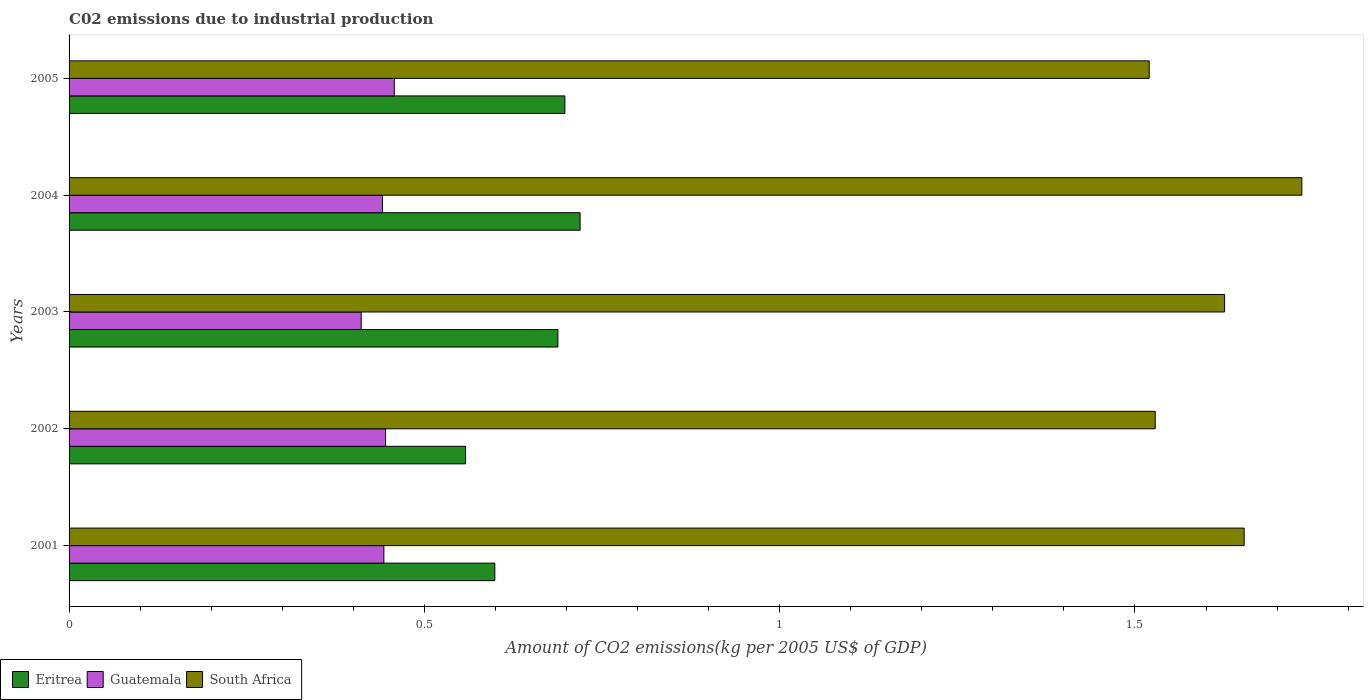How many groups of bars are there?
Make the answer very short. 5. Are the number of bars on each tick of the Y-axis equal?
Give a very brief answer. Yes. In how many cases, is the number of bars for a given year not equal to the number of legend labels?
Keep it short and to the point. 0. What is the amount of CO2 emitted due to industrial production in Guatemala in 2001?
Your answer should be very brief. 0.44. Across all years, what is the maximum amount of CO2 emitted due to industrial production in Eritrea?
Give a very brief answer. 0.72. Across all years, what is the minimum amount of CO2 emitted due to industrial production in South Africa?
Your answer should be very brief. 1.52. In which year was the amount of CO2 emitted due to industrial production in Guatemala maximum?
Your answer should be compact. 2005. What is the total amount of CO2 emitted due to industrial production in South Africa in the graph?
Make the answer very short. 8.06. What is the difference between the amount of CO2 emitted due to industrial production in South Africa in 2003 and that in 2004?
Offer a very short reply. -0.11. What is the difference between the amount of CO2 emitted due to industrial production in South Africa in 2005 and the amount of CO2 emitted due to industrial production in Eritrea in 2003?
Provide a succinct answer. 0.83. What is the average amount of CO2 emitted due to industrial production in Eritrea per year?
Offer a terse response. 0.65. In the year 2003, what is the difference between the amount of CO2 emitted due to industrial production in South Africa and amount of CO2 emitted due to industrial production in Guatemala?
Your answer should be very brief. 1.22. What is the ratio of the amount of CO2 emitted due to industrial production in Eritrea in 2001 to that in 2002?
Ensure brevity in your answer.  1.07. Is the difference between the amount of CO2 emitted due to industrial production in South Africa in 2004 and 2005 greater than the difference between the amount of CO2 emitted due to industrial production in Guatemala in 2004 and 2005?
Your answer should be compact. Yes. What is the difference between the highest and the second highest amount of CO2 emitted due to industrial production in Eritrea?
Your answer should be compact. 0.02. What is the difference between the highest and the lowest amount of CO2 emitted due to industrial production in Guatemala?
Your answer should be very brief. 0.05. Is the sum of the amount of CO2 emitted due to industrial production in Guatemala in 2001 and 2005 greater than the maximum amount of CO2 emitted due to industrial production in South Africa across all years?
Give a very brief answer. No. What does the 1st bar from the top in 2001 represents?
Your answer should be very brief. South Africa. What does the 3rd bar from the bottom in 2001 represents?
Your response must be concise. South Africa. Is it the case that in every year, the sum of the amount of CO2 emitted due to industrial production in South Africa and amount of CO2 emitted due to industrial production in Guatemala is greater than the amount of CO2 emitted due to industrial production in Eritrea?
Keep it short and to the point. Yes. Are all the bars in the graph horizontal?
Your answer should be very brief. Yes. How many legend labels are there?
Provide a short and direct response. 3. What is the title of the graph?
Your answer should be compact. C02 emissions due to industrial production. What is the label or title of the X-axis?
Offer a very short reply. Amount of CO2 emissions(kg per 2005 US$ of GDP). What is the label or title of the Y-axis?
Make the answer very short. Years. What is the Amount of CO2 emissions(kg per 2005 US$ of GDP) in Eritrea in 2001?
Keep it short and to the point. 0.6. What is the Amount of CO2 emissions(kg per 2005 US$ of GDP) in Guatemala in 2001?
Keep it short and to the point. 0.44. What is the Amount of CO2 emissions(kg per 2005 US$ of GDP) in South Africa in 2001?
Keep it short and to the point. 1.65. What is the Amount of CO2 emissions(kg per 2005 US$ of GDP) in Eritrea in 2002?
Offer a terse response. 0.56. What is the Amount of CO2 emissions(kg per 2005 US$ of GDP) of Guatemala in 2002?
Keep it short and to the point. 0.45. What is the Amount of CO2 emissions(kg per 2005 US$ of GDP) of South Africa in 2002?
Your response must be concise. 1.53. What is the Amount of CO2 emissions(kg per 2005 US$ of GDP) in Eritrea in 2003?
Offer a very short reply. 0.69. What is the Amount of CO2 emissions(kg per 2005 US$ of GDP) in Guatemala in 2003?
Give a very brief answer. 0.41. What is the Amount of CO2 emissions(kg per 2005 US$ of GDP) of South Africa in 2003?
Offer a terse response. 1.63. What is the Amount of CO2 emissions(kg per 2005 US$ of GDP) in Eritrea in 2004?
Your response must be concise. 0.72. What is the Amount of CO2 emissions(kg per 2005 US$ of GDP) of Guatemala in 2004?
Make the answer very short. 0.44. What is the Amount of CO2 emissions(kg per 2005 US$ of GDP) in South Africa in 2004?
Make the answer very short. 1.73. What is the Amount of CO2 emissions(kg per 2005 US$ of GDP) in Eritrea in 2005?
Your answer should be very brief. 0.7. What is the Amount of CO2 emissions(kg per 2005 US$ of GDP) in Guatemala in 2005?
Your answer should be very brief. 0.46. What is the Amount of CO2 emissions(kg per 2005 US$ of GDP) in South Africa in 2005?
Give a very brief answer. 1.52. Across all years, what is the maximum Amount of CO2 emissions(kg per 2005 US$ of GDP) of Eritrea?
Offer a very short reply. 0.72. Across all years, what is the maximum Amount of CO2 emissions(kg per 2005 US$ of GDP) in Guatemala?
Provide a succinct answer. 0.46. Across all years, what is the maximum Amount of CO2 emissions(kg per 2005 US$ of GDP) of South Africa?
Offer a terse response. 1.73. Across all years, what is the minimum Amount of CO2 emissions(kg per 2005 US$ of GDP) of Eritrea?
Ensure brevity in your answer.  0.56. Across all years, what is the minimum Amount of CO2 emissions(kg per 2005 US$ of GDP) in Guatemala?
Your response must be concise. 0.41. Across all years, what is the minimum Amount of CO2 emissions(kg per 2005 US$ of GDP) of South Africa?
Your answer should be very brief. 1.52. What is the total Amount of CO2 emissions(kg per 2005 US$ of GDP) of Eritrea in the graph?
Keep it short and to the point. 3.26. What is the total Amount of CO2 emissions(kg per 2005 US$ of GDP) of Guatemala in the graph?
Your response must be concise. 2.2. What is the total Amount of CO2 emissions(kg per 2005 US$ of GDP) in South Africa in the graph?
Offer a terse response. 8.06. What is the difference between the Amount of CO2 emissions(kg per 2005 US$ of GDP) of Eritrea in 2001 and that in 2002?
Keep it short and to the point. 0.04. What is the difference between the Amount of CO2 emissions(kg per 2005 US$ of GDP) of Guatemala in 2001 and that in 2002?
Your response must be concise. -0. What is the difference between the Amount of CO2 emissions(kg per 2005 US$ of GDP) of South Africa in 2001 and that in 2002?
Provide a short and direct response. 0.13. What is the difference between the Amount of CO2 emissions(kg per 2005 US$ of GDP) in Eritrea in 2001 and that in 2003?
Offer a very short reply. -0.09. What is the difference between the Amount of CO2 emissions(kg per 2005 US$ of GDP) of Guatemala in 2001 and that in 2003?
Your answer should be very brief. 0.03. What is the difference between the Amount of CO2 emissions(kg per 2005 US$ of GDP) of South Africa in 2001 and that in 2003?
Give a very brief answer. 0.03. What is the difference between the Amount of CO2 emissions(kg per 2005 US$ of GDP) of Eritrea in 2001 and that in 2004?
Keep it short and to the point. -0.12. What is the difference between the Amount of CO2 emissions(kg per 2005 US$ of GDP) in Guatemala in 2001 and that in 2004?
Provide a short and direct response. 0. What is the difference between the Amount of CO2 emissions(kg per 2005 US$ of GDP) in South Africa in 2001 and that in 2004?
Your answer should be very brief. -0.08. What is the difference between the Amount of CO2 emissions(kg per 2005 US$ of GDP) in Eritrea in 2001 and that in 2005?
Your answer should be very brief. -0.1. What is the difference between the Amount of CO2 emissions(kg per 2005 US$ of GDP) of Guatemala in 2001 and that in 2005?
Offer a terse response. -0.01. What is the difference between the Amount of CO2 emissions(kg per 2005 US$ of GDP) of South Africa in 2001 and that in 2005?
Offer a terse response. 0.13. What is the difference between the Amount of CO2 emissions(kg per 2005 US$ of GDP) in Eritrea in 2002 and that in 2003?
Provide a succinct answer. -0.13. What is the difference between the Amount of CO2 emissions(kg per 2005 US$ of GDP) of Guatemala in 2002 and that in 2003?
Your answer should be compact. 0.03. What is the difference between the Amount of CO2 emissions(kg per 2005 US$ of GDP) of South Africa in 2002 and that in 2003?
Provide a short and direct response. -0.1. What is the difference between the Amount of CO2 emissions(kg per 2005 US$ of GDP) of Eritrea in 2002 and that in 2004?
Ensure brevity in your answer.  -0.16. What is the difference between the Amount of CO2 emissions(kg per 2005 US$ of GDP) in Guatemala in 2002 and that in 2004?
Your answer should be very brief. 0. What is the difference between the Amount of CO2 emissions(kg per 2005 US$ of GDP) in South Africa in 2002 and that in 2004?
Your response must be concise. -0.21. What is the difference between the Amount of CO2 emissions(kg per 2005 US$ of GDP) in Eritrea in 2002 and that in 2005?
Offer a very short reply. -0.14. What is the difference between the Amount of CO2 emissions(kg per 2005 US$ of GDP) of Guatemala in 2002 and that in 2005?
Ensure brevity in your answer.  -0.01. What is the difference between the Amount of CO2 emissions(kg per 2005 US$ of GDP) of South Africa in 2002 and that in 2005?
Ensure brevity in your answer.  0.01. What is the difference between the Amount of CO2 emissions(kg per 2005 US$ of GDP) of Eritrea in 2003 and that in 2004?
Provide a succinct answer. -0.03. What is the difference between the Amount of CO2 emissions(kg per 2005 US$ of GDP) in Guatemala in 2003 and that in 2004?
Offer a very short reply. -0.03. What is the difference between the Amount of CO2 emissions(kg per 2005 US$ of GDP) in South Africa in 2003 and that in 2004?
Your answer should be very brief. -0.11. What is the difference between the Amount of CO2 emissions(kg per 2005 US$ of GDP) in Eritrea in 2003 and that in 2005?
Offer a very short reply. -0.01. What is the difference between the Amount of CO2 emissions(kg per 2005 US$ of GDP) of Guatemala in 2003 and that in 2005?
Your answer should be compact. -0.05. What is the difference between the Amount of CO2 emissions(kg per 2005 US$ of GDP) of South Africa in 2003 and that in 2005?
Your answer should be compact. 0.11. What is the difference between the Amount of CO2 emissions(kg per 2005 US$ of GDP) of Eritrea in 2004 and that in 2005?
Offer a very short reply. 0.02. What is the difference between the Amount of CO2 emissions(kg per 2005 US$ of GDP) of Guatemala in 2004 and that in 2005?
Provide a succinct answer. -0.02. What is the difference between the Amount of CO2 emissions(kg per 2005 US$ of GDP) of South Africa in 2004 and that in 2005?
Offer a very short reply. 0.21. What is the difference between the Amount of CO2 emissions(kg per 2005 US$ of GDP) in Eritrea in 2001 and the Amount of CO2 emissions(kg per 2005 US$ of GDP) in Guatemala in 2002?
Provide a short and direct response. 0.15. What is the difference between the Amount of CO2 emissions(kg per 2005 US$ of GDP) of Eritrea in 2001 and the Amount of CO2 emissions(kg per 2005 US$ of GDP) of South Africa in 2002?
Your answer should be compact. -0.93. What is the difference between the Amount of CO2 emissions(kg per 2005 US$ of GDP) in Guatemala in 2001 and the Amount of CO2 emissions(kg per 2005 US$ of GDP) in South Africa in 2002?
Offer a very short reply. -1.09. What is the difference between the Amount of CO2 emissions(kg per 2005 US$ of GDP) in Eritrea in 2001 and the Amount of CO2 emissions(kg per 2005 US$ of GDP) in Guatemala in 2003?
Offer a very short reply. 0.19. What is the difference between the Amount of CO2 emissions(kg per 2005 US$ of GDP) in Eritrea in 2001 and the Amount of CO2 emissions(kg per 2005 US$ of GDP) in South Africa in 2003?
Give a very brief answer. -1.03. What is the difference between the Amount of CO2 emissions(kg per 2005 US$ of GDP) of Guatemala in 2001 and the Amount of CO2 emissions(kg per 2005 US$ of GDP) of South Africa in 2003?
Your response must be concise. -1.18. What is the difference between the Amount of CO2 emissions(kg per 2005 US$ of GDP) in Eritrea in 2001 and the Amount of CO2 emissions(kg per 2005 US$ of GDP) in Guatemala in 2004?
Your response must be concise. 0.16. What is the difference between the Amount of CO2 emissions(kg per 2005 US$ of GDP) in Eritrea in 2001 and the Amount of CO2 emissions(kg per 2005 US$ of GDP) in South Africa in 2004?
Keep it short and to the point. -1.14. What is the difference between the Amount of CO2 emissions(kg per 2005 US$ of GDP) in Guatemala in 2001 and the Amount of CO2 emissions(kg per 2005 US$ of GDP) in South Africa in 2004?
Provide a succinct answer. -1.29. What is the difference between the Amount of CO2 emissions(kg per 2005 US$ of GDP) in Eritrea in 2001 and the Amount of CO2 emissions(kg per 2005 US$ of GDP) in Guatemala in 2005?
Your answer should be compact. 0.14. What is the difference between the Amount of CO2 emissions(kg per 2005 US$ of GDP) in Eritrea in 2001 and the Amount of CO2 emissions(kg per 2005 US$ of GDP) in South Africa in 2005?
Ensure brevity in your answer.  -0.92. What is the difference between the Amount of CO2 emissions(kg per 2005 US$ of GDP) in Guatemala in 2001 and the Amount of CO2 emissions(kg per 2005 US$ of GDP) in South Africa in 2005?
Give a very brief answer. -1.08. What is the difference between the Amount of CO2 emissions(kg per 2005 US$ of GDP) of Eritrea in 2002 and the Amount of CO2 emissions(kg per 2005 US$ of GDP) of Guatemala in 2003?
Make the answer very short. 0.15. What is the difference between the Amount of CO2 emissions(kg per 2005 US$ of GDP) of Eritrea in 2002 and the Amount of CO2 emissions(kg per 2005 US$ of GDP) of South Africa in 2003?
Offer a terse response. -1.07. What is the difference between the Amount of CO2 emissions(kg per 2005 US$ of GDP) in Guatemala in 2002 and the Amount of CO2 emissions(kg per 2005 US$ of GDP) in South Africa in 2003?
Your answer should be very brief. -1.18. What is the difference between the Amount of CO2 emissions(kg per 2005 US$ of GDP) of Eritrea in 2002 and the Amount of CO2 emissions(kg per 2005 US$ of GDP) of Guatemala in 2004?
Ensure brevity in your answer.  0.12. What is the difference between the Amount of CO2 emissions(kg per 2005 US$ of GDP) in Eritrea in 2002 and the Amount of CO2 emissions(kg per 2005 US$ of GDP) in South Africa in 2004?
Give a very brief answer. -1.18. What is the difference between the Amount of CO2 emissions(kg per 2005 US$ of GDP) in Guatemala in 2002 and the Amount of CO2 emissions(kg per 2005 US$ of GDP) in South Africa in 2004?
Your answer should be very brief. -1.29. What is the difference between the Amount of CO2 emissions(kg per 2005 US$ of GDP) in Eritrea in 2002 and the Amount of CO2 emissions(kg per 2005 US$ of GDP) in Guatemala in 2005?
Your answer should be compact. 0.1. What is the difference between the Amount of CO2 emissions(kg per 2005 US$ of GDP) in Eritrea in 2002 and the Amount of CO2 emissions(kg per 2005 US$ of GDP) in South Africa in 2005?
Your answer should be very brief. -0.96. What is the difference between the Amount of CO2 emissions(kg per 2005 US$ of GDP) of Guatemala in 2002 and the Amount of CO2 emissions(kg per 2005 US$ of GDP) of South Africa in 2005?
Ensure brevity in your answer.  -1.07. What is the difference between the Amount of CO2 emissions(kg per 2005 US$ of GDP) in Eritrea in 2003 and the Amount of CO2 emissions(kg per 2005 US$ of GDP) in Guatemala in 2004?
Your answer should be very brief. 0.25. What is the difference between the Amount of CO2 emissions(kg per 2005 US$ of GDP) in Eritrea in 2003 and the Amount of CO2 emissions(kg per 2005 US$ of GDP) in South Africa in 2004?
Ensure brevity in your answer.  -1.05. What is the difference between the Amount of CO2 emissions(kg per 2005 US$ of GDP) of Guatemala in 2003 and the Amount of CO2 emissions(kg per 2005 US$ of GDP) of South Africa in 2004?
Offer a terse response. -1.32. What is the difference between the Amount of CO2 emissions(kg per 2005 US$ of GDP) in Eritrea in 2003 and the Amount of CO2 emissions(kg per 2005 US$ of GDP) in Guatemala in 2005?
Your response must be concise. 0.23. What is the difference between the Amount of CO2 emissions(kg per 2005 US$ of GDP) in Eritrea in 2003 and the Amount of CO2 emissions(kg per 2005 US$ of GDP) in South Africa in 2005?
Your response must be concise. -0.83. What is the difference between the Amount of CO2 emissions(kg per 2005 US$ of GDP) of Guatemala in 2003 and the Amount of CO2 emissions(kg per 2005 US$ of GDP) of South Africa in 2005?
Give a very brief answer. -1.11. What is the difference between the Amount of CO2 emissions(kg per 2005 US$ of GDP) of Eritrea in 2004 and the Amount of CO2 emissions(kg per 2005 US$ of GDP) of Guatemala in 2005?
Ensure brevity in your answer.  0.26. What is the difference between the Amount of CO2 emissions(kg per 2005 US$ of GDP) of Eritrea in 2004 and the Amount of CO2 emissions(kg per 2005 US$ of GDP) of South Africa in 2005?
Keep it short and to the point. -0.8. What is the difference between the Amount of CO2 emissions(kg per 2005 US$ of GDP) in Guatemala in 2004 and the Amount of CO2 emissions(kg per 2005 US$ of GDP) in South Africa in 2005?
Offer a very short reply. -1.08. What is the average Amount of CO2 emissions(kg per 2005 US$ of GDP) of Eritrea per year?
Offer a very short reply. 0.65. What is the average Amount of CO2 emissions(kg per 2005 US$ of GDP) in Guatemala per year?
Provide a succinct answer. 0.44. What is the average Amount of CO2 emissions(kg per 2005 US$ of GDP) in South Africa per year?
Your answer should be compact. 1.61. In the year 2001, what is the difference between the Amount of CO2 emissions(kg per 2005 US$ of GDP) in Eritrea and Amount of CO2 emissions(kg per 2005 US$ of GDP) in Guatemala?
Your answer should be compact. 0.16. In the year 2001, what is the difference between the Amount of CO2 emissions(kg per 2005 US$ of GDP) in Eritrea and Amount of CO2 emissions(kg per 2005 US$ of GDP) in South Africa?
Your answer should be very brief. -1.05. In the year 2001, what is the difference between the Amount of CO2 emissions(kg per 2005 US$ of GDP) in Guatemala and Amount of CO2 emissions(kg per 2005 US$ of GDP) in South Africa?
Provide a succinct answer. -1.21. In the year 2002, what is the difference between the Amount of CO2 emissions(kg per 2005 US$ of GDP) of Eritrea and Amount of CO2 emissions(kg per 2005 US$ of GDP) of Guatemala?
Provide a succinct answer. 0.11. In the year 2002, what is the difference between the Amount of CO2 emissions(kg per 2005 US$ of GDP) of Eritrea and Amount of CO2 emissions(kg per 2005 US$ of GDP) of South Africa?
Make the answer very short. -0.97. In the year 2002, what is the difference between the Amount of CO2 emissions(kg per 2005 US$ of GDP) of Guatemala and Amount of CO2 emissions(kg per 2005 US$ of GDP) of South Africa?
Make the answer very short. -1.08. In the year 2003, what is the difference between the Amount of CO2 emissions(kg per 2005 US$ of GDP) in Eritrea and Amount of CO2 emissions(kg per 2005 US$ of GDP) in Guatemala?
Offer a terse response. 0.28. In the year 2003, what is the difference between the Amount of CO2 emissions(kg per 2005 US$ of GDP) of Eritrea and Amount of CO2 emissions(kg per 2005 US$ of GDP) of South Africa?
Your answer should be very brief. -0.94. In the year 2003, what is the difference between the Amount of CO2 emissions(kg per 2005 US$ of GDP) in Guatemala and Amount of CO2 emissions(kg per 2005 US$ of GDP) in South Africa?
Provide a short and direct response. -1.22. In the year 2004, what is the difference between the Amount of CO2 emissions(kg per 2005 US$ of GDP) in Eritrea and Amount of CO2 emissions(kg per 2005 US$ of GDP) in Guatemala?
Offer a very short reply. 0.28. In the year 2004, what is the difference between the Amount of CO2 emissions(kg per 2005 US$ of GDP) of Eritrea and Amount of CO2 emissions(kg per 2005 US$ of GDP) of South Africa?
Offer a very short reply. -1.02. In the year 2004, what is the difference between the Amount of CO2 emissions(kg per 2005 US$ of GDP) in Guatemala and Amount of CO2 emissions(kg per 2005 US$ of GDP) in South Africa?
Your answer should be very brief. -1.29. In the year 2005, what is the difference between the Amount of CO2 emissions(kg per 2005 US$ of GDP) of Eritrea and Amount of CO2 emissions(kg per 2005 US$ of GDP) of Guatemala?
Ensure brevity in your answer.  0.24. In the year 2005, what is the difference between the Amount of CO2 emissions(kg per 2005 US$ of GDP) in Eritrea and Amount of CO2 emissions(kg per 2005 US$ of GDP) in South Africa?
Offer a terse response. -0.82. In the year 2005, what is the difference between the Amount of CO2 emissions(kg per 2005 US$ of GDP) in Guatemala and Amount of CO2 emissions(kg per 2005 US$ of GDP) in South Africa?
Your answer should be compact. -1.06. What is the ratio of the Amount of CO2 emissions(kg per 2005 US$ of GDP) of Eritrea in 2001 to that in 2002?
Ensure brevity in your answer.  1.07. What is the ratio of the Amount of CO2 emissions(kg per 2005 US$ of GDP) in South Africa in 2001 to that in 2002?
Keep it short and to the point. 1.08. What is the ratio of the Amount of CO2 emissions(kg per 2005 US$ of GDP) in Eritrea in 2001 to that in 2003?
Provide a short and direct response. 0.87. What is the ratio of the Amount of CO2 emissions(kg per 2005 US$ of GDP) of Guatemala in 2001 to that in 2003?
Provide a succinct answer. 1.08. What is the ratio of the Amount of CO2 emissions(kg per 2005 US$ of GDP) of South Africa in 2001 to that in 2003?
Provide a short and direct response. 1.02. What is the ratio of the Amount of CO2 emissions(kg per 2005 US$ of GDP) of Eritrea in 2001 to that in 2004?
Keep it short and to the point. 0.83. What is the ratio of the Amount of CO2 emissions(kg per 2005 US$ of GDP) of South Africa in 2001 to that in 2004?
Offer a very short reply. 0.95. What is the ratio of the Amount of CO2 emissions(kg per 2005 US$ of GDP) of Eritrea in 2001 to that in 2005?
Keep it short and to the point. 0.86. What is the ratio of the Amount of CO2 emissions(kg per 2005 US$ of GDP) of Guatemala in 2001 to that in 2005?
Ensure brevity in your answer.  0.97. What is the ratio of the Amount of CO2 emissions(kg per 2005 US$ of GDP) in South Africa in 2001 to that in 2005?
Provide a succinct answer. 1.09. What is the ratio of the Amount of CO2 emissions(kg per 2005 US$ of GDP) in Eritrea in 2002 to that in 2003?
Make the answer very short. 0.81. What is the ratio of the Amount of CO2 emissions(kg per 2005 US$ of GDP) in Guatemala in 2002 to that in 2003?
Your answer should be very brief. 1.08. What is the ratio of the Amount of CO2 emissions(kg per 2005 US$ of GDP) in South Africa in 2002 to that in 2003?
Offer a terse response. 0.94. What is the ratio of the Amount of CO2 emissions(kg per 2005 US$ of GDP) in Eritrea in 2002 to that in 2004?
Offer a very short reply. 0.78. What is the ratio of the Amount of CO2 emissions(kg per 2005 US$ of GDP) of Guatemala in 2002 to that in 2004?
Provide a succinct answer. 1.01. What is the ratio of the Amount of CO2 emissions(kg per 2005 US$ of GDP) in South Africa in 2002 to that in 2004?
Provide a succinct answer. 0.88. What is the ratio of the Amount of CO2 emissions(kg per 2005 US$ of GDP) of Eritrea in 2002 to that in 2005?
Give a very brief answer. 0.8. What is the ratio of the Amount of CO2 emissions(kg per 2005 US$ of GDP) of Guatemala in 2002 to that in 2005?
Keep it short and to the point. 0.97. What is the ratio of the Amount of CO2 emissions(kg per 2005 US$ of GDP) of Eritrea in 2003 to that in 2004?
Your response must be concise. 0.96. What is the ratio of the Amount of CO2 emissions(kg per 2005 US$ of GDP) of Guatemala in 2003 to that in 2004?
Your response must be concise. 0.93. What is the ratio of the Amount of CO2 emissions(kg per 2005 US$ of GDP) in South Africa in 2003 to that in 2004?
Ensure brevity in your answer.  0.94. What is the ratio of the Amount of CO2 emissions(kg per 2005 US$ of GDP) in Eritrea in 2003 to that in 2005?
Make the answer very short. 0.99. What is the ratio of the Amount of CO2 emissions(kg per 2005 US$ of GDP) of Guatemala in 2003 to that in 2005?
Make the answer very short. 0.9. What is the ratio of the Amount of CO2 emissions(kg per 2005 US$ of GDP) of South Africa in 2003 to that in 2005?
Your answer should be compact. 1.07. What is the ratio of the Amount of CO2 emissions(kg per 2005 US$ of GDP) of Eritrea in 2004 to that in 2005?
Your response must be concise. 1.03. What is the ratio of the Amount of CO2 emissions(kg per 2005 US$ of GDP) in Guatemala in 2004 to that in 2005?
Keep it short and to the point. 0.96. What is the ratio of the Amount of CO2 emissions(kg per 2005 US$ of GDP) of South Africa in 2004 to that in 2005?
Provide a short and direct response. 1.14. What is the difference between the highest and the second highest Amount of CO2 emissions(kg per 2005 US$ of GDP) in Eritrea?
Provide a short and direct response. 0.02. What is the difference between the highest and the second highest Amount of CO2 emissions(kg per 2005 US$ of GDP) in Guatemala?
Offer a very short reply. 0.01. What is the difference between the highest and the second highest Amount of CO2 emissions(kg per 2005 US$ of GDP) of South Africa?
Offer a terse response. 0.08. What is the difference between the highest and the lowest Amount of CO2 emissions(kg per 2005 US$ of GDP) of Eritrea?
Make the answer very short. 0.16. What is the difference between the highest and the lowest Amount of CO2 emissions(kg per 2005 US$ of GDP) in Guatemala?
Provide a short and direct response. 0.05. What is the difference between the highest and the lowest Amount of CO2 emissions(kg per 2005 US$ of GDP) of South Africa?
Provide a short and direct response. 0.21. 